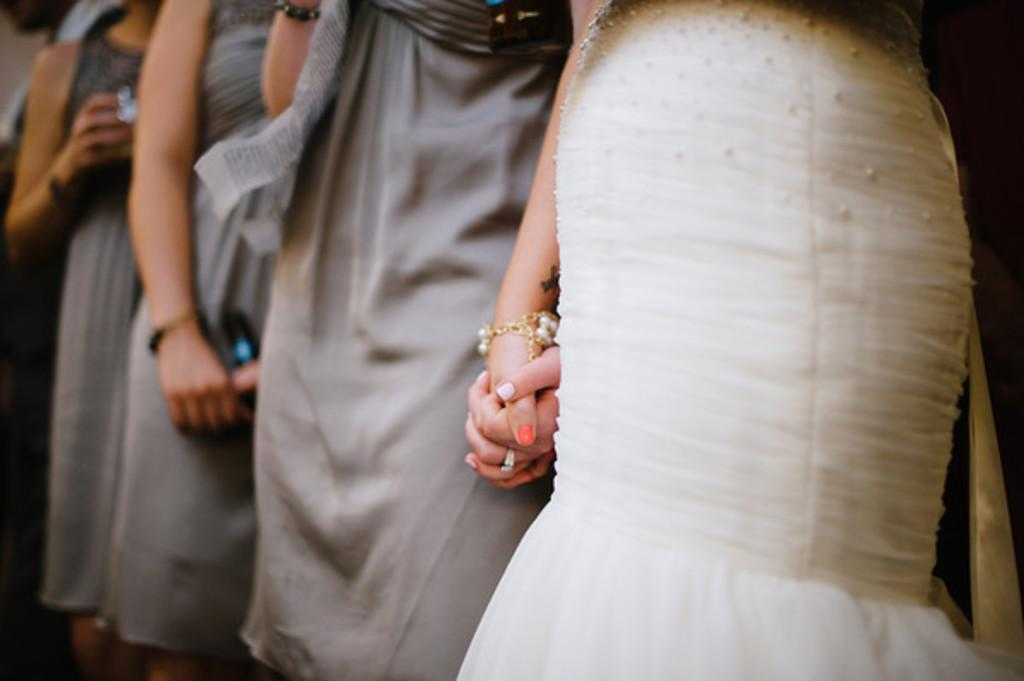What is the main subject of the image? The main subject of the image is women standing together. Can you describe the clothing of one of the women? One woman is wearing a white dress. What is the relationship between the women in the image? The woman in the white dress is holding the hand of another woman. What type of goat can be seen in the image? There is no goat present in the image. How does the cork affect the weather in the image? There is no cork or reference to weather in the image. 